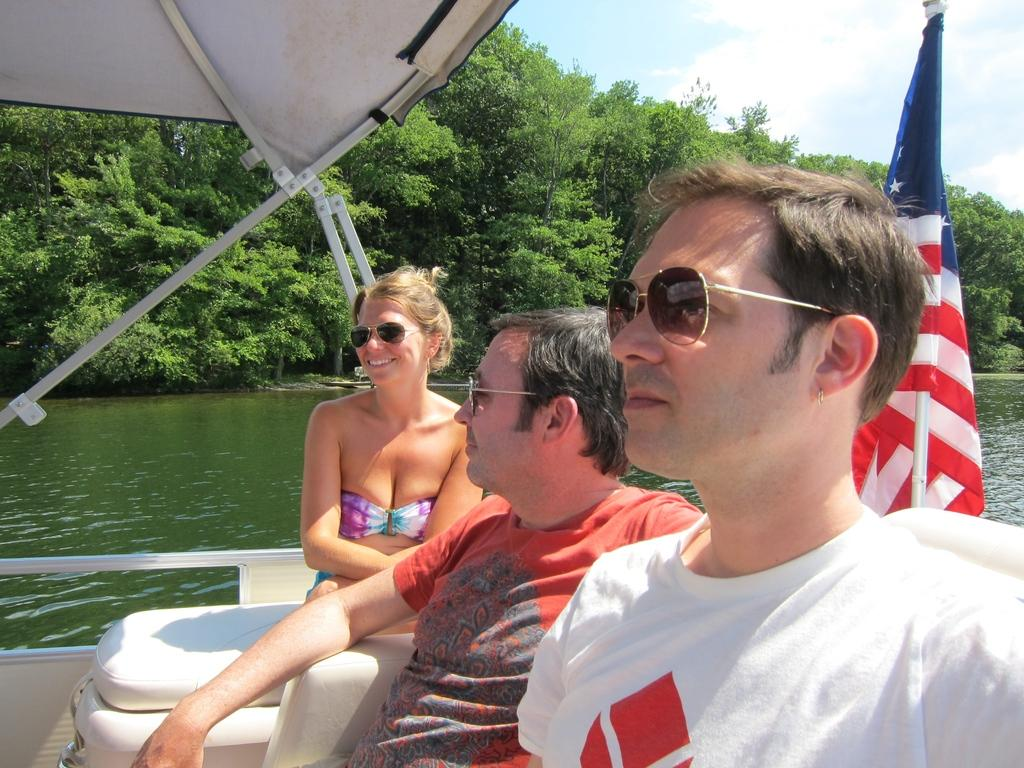How many people are in the image? There are three people in the image. What are the people doing in the image? The people are sitting on a boat. What is attached to the boat? There is a flag on the boat. What can be seen in the background of the image? There are trees in the background of the image. How would you describe the sky in the image? The sky is blue and cloudy. What type of sticks are being used to write letters on the popcorn in the image? There is no popcorn, sticks, or letters present in the image. 